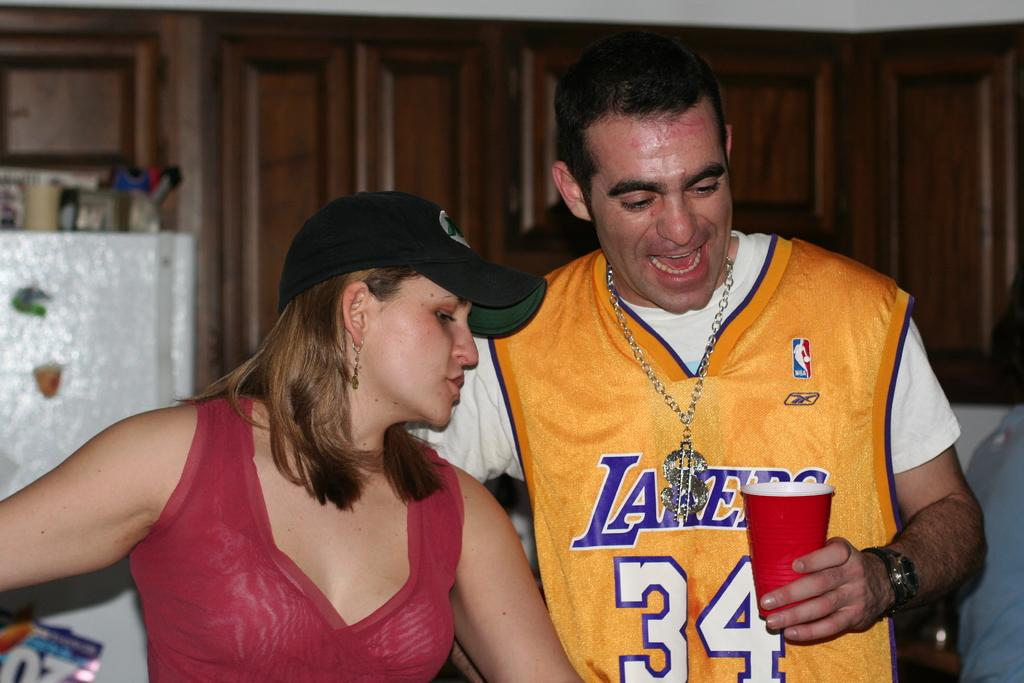Provide a one-sentence caption for the provided image. A man wearing a Laker's jersey stands in a kitchen with a woman. 